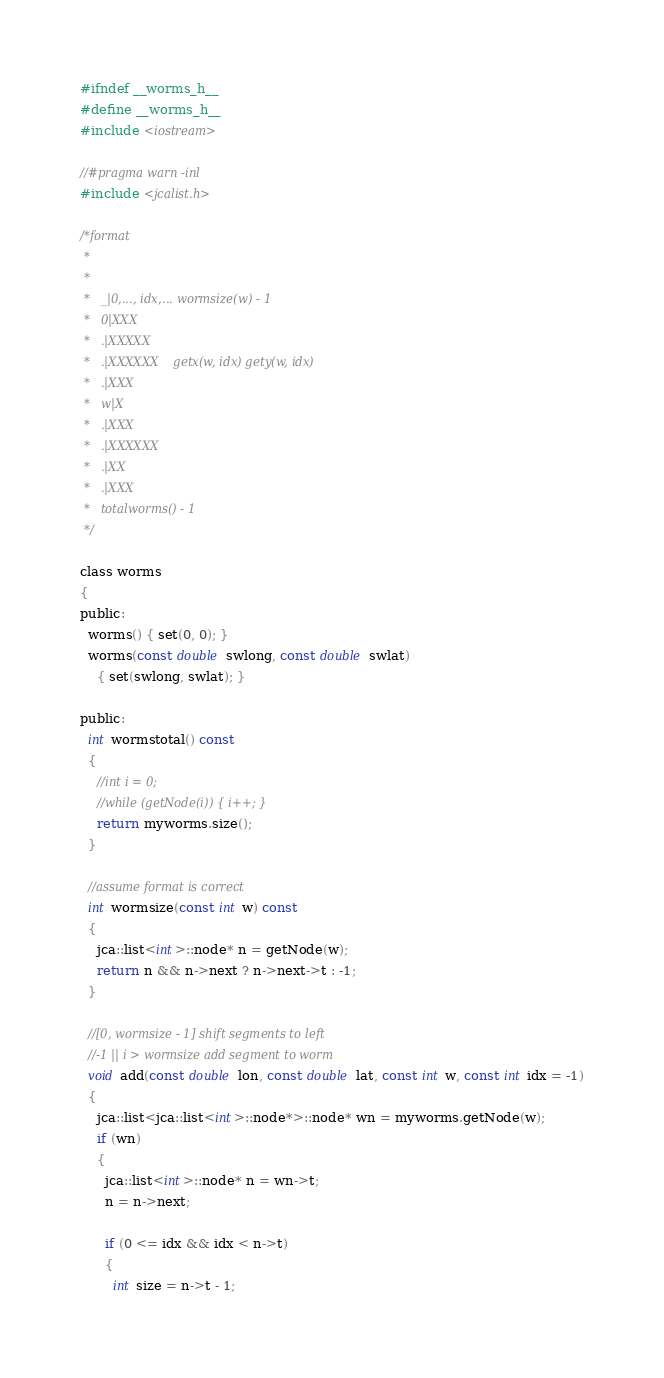<code> <loc_0><loc_0><loc_500><loc_500><_C_>#ifndef __worms_h__
#define __worms_h__
#include <iostream>

//#pragma warn -inl
#include <jcalist.h>

/*format 
 *
 *
 *   _|0,..., idx,... wormsize(w) - 1
 *   0|XXX
 *   .|XXXXX
 *   .|XXXXXX    getx(w, idx) gety(w, idx)
 *   .|XXX
 *   w|X
 *   .|XXX
 *   .|XXXXXX
 *   .|XX
 *   .|XXX
 *   totalworms() - 1
 */

class worms
{
public:
  worms() { set(0, 0); } 
  worms(const double swlong, const double swlat)
    { set(swlong, swlat); } 

public:
  int wormstotal() const
  {
    //int i = 0;
    //while (getNode(i)) { i++; }
    return myworms.size();
  }

  //assume format is correct
  int wormsize(const int w) const
  {
    jca::list<int>::node* n = getNode(w);
    return n && n->next ? n->next->t : -1;
  }

  //[0, wormsize - 1] shift segments to left
  //-1 || i > wormsize add segment to worm
  void add(const double lon, const double lat, const int w, const int idx = -1)
  { 
    jca::list<jca::list<int>::node*>::node* wn = myworms.getNode(w);
    if (wn)
    {
      jca::list<int>::node* n = wn->t;
      n = n->next;

      if (0 <= idx && idx < n->t)
      {
        int size = n->t - 1;
</code> 